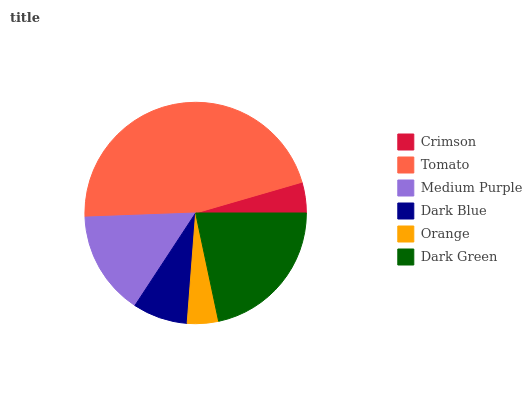Is Crimson the minimum?
Answer yes or no. Yes. Is Tomato the maximum?
Answer yes or no. Yes. Is Medium Purple the minimum?
Answer yes or no. No. Is Medium Purple the maximum?
Answer yes or no. No. Is Tomato greater than Medium Purple?
Answer yes or no. Yes. Is Medium Purple less than Tomato?
Answer yes or no. Yes. Is Medium Purple greater than Tomato?
Answer yes or no. No. Is Tomato less than Medium Purple?
Answer yes or no. No. Is Medium Purple the high median?
Answer yes or no. Yes. Is Dark Blue the low median?
Answer yes or no. Yes. Is Dark Green the high median?
Answer yes or no. No. Is Tomato the low median?
Answer yes or no. No. 